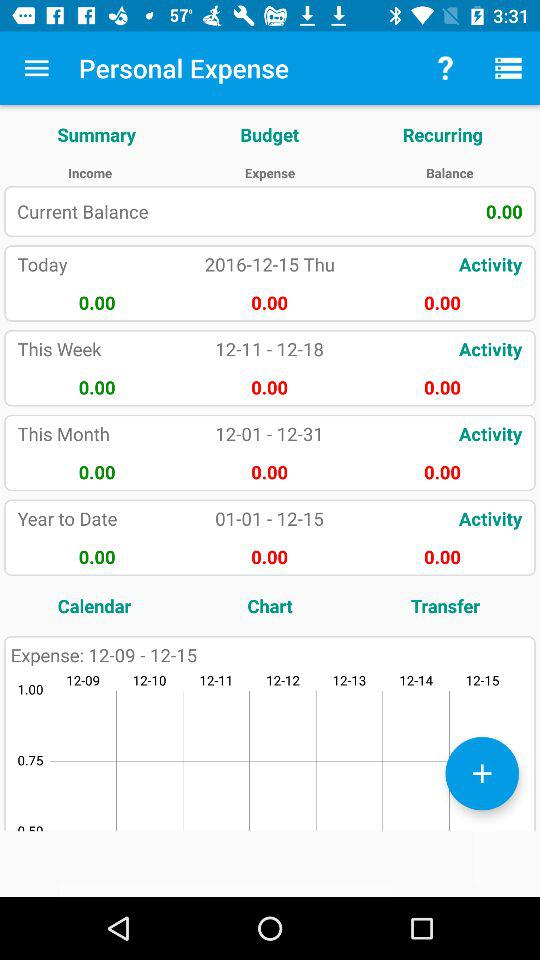Is "Budget" checked on unchecked?
When the provided information is insufficient, respond with <no answer>. <no answer> 